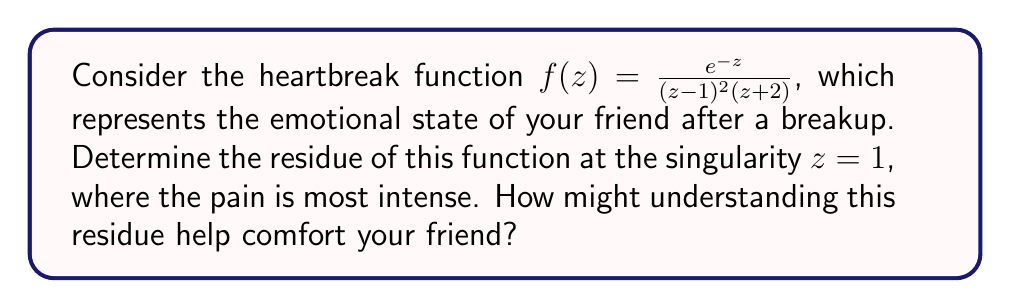Can you solve this math problem? To determine the residue of the heartbreak function at $z=1$, we need to follow these steps:

1) First, we identify that $z=1$ is a pole of order 2, as $(z-1)^2$ appears in the denominator.

2) For a pole of order 2, we use the formula:

   $$\text{Res}(f,1) = \lim_{z \to 1} \frac{d}{dz}\left[(z-1)^2f(z)\right]$$

3) Let's simplify $(z-1)^2f(z)$:

   $$(z-1)^2f(z) = \frac{e^{-z}}{z+2}$$

4) Now we need to differentiate this with respect to $z$:

   $$\frac{d}{dz}\left[\frac{e^{-z}}{z+2}\right] = \frac{-e^{-z}(z+2) - e^{-z}}{(z+2)^2} = -\frac{e^{-z}(z+3)}{(z+2)^2}$$

5) Finally, we take the limit as $z$ approaches 1:

   $$\lim_{z \to 1} -\frac{e^{-z}(z+3)}{(z+2)^2} = -\frac{e^{-1}(1+3)}{(1+2)^2} = -\frac{4e^{-1}}{9}$$

Understanding this residue can help comfort your friend by showing that the intensity of the heartbreak (represented by the residue) is finite and quantifiable. It suggests that the pain, while significant, is not infinite and will eventually subside.
Answer: The residue of the heartbreak function at $z=1$ is $-\frac{4e^{-1}}{9}$. 